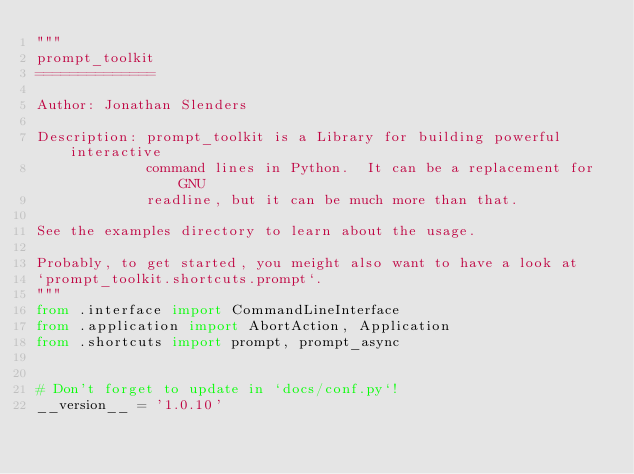<code> <loc_0><loc_0><loc_500><loc_500><_Python_>"""
prompt_toolkit
==============

Author: Jonathan Slenders

Description: prompt_toolkit is a Library for building powerful interactive
             command lines in Python.  It can be a replacement for GNU
             readline, but it can be much more than that.

See the examples directory to learn about the usage.

Probably, to get started, you meight also want to have a look at
`prompt_toolkit.shortcuts.prompt`.
"""
from .interface import CommandLineInterface
from .application import AbortAction, Application
from .shortcuts import prompt, prompt_async


# Don't forget to update in `docs/conf.py`!
__version__ = '1.0.10'
</code> 